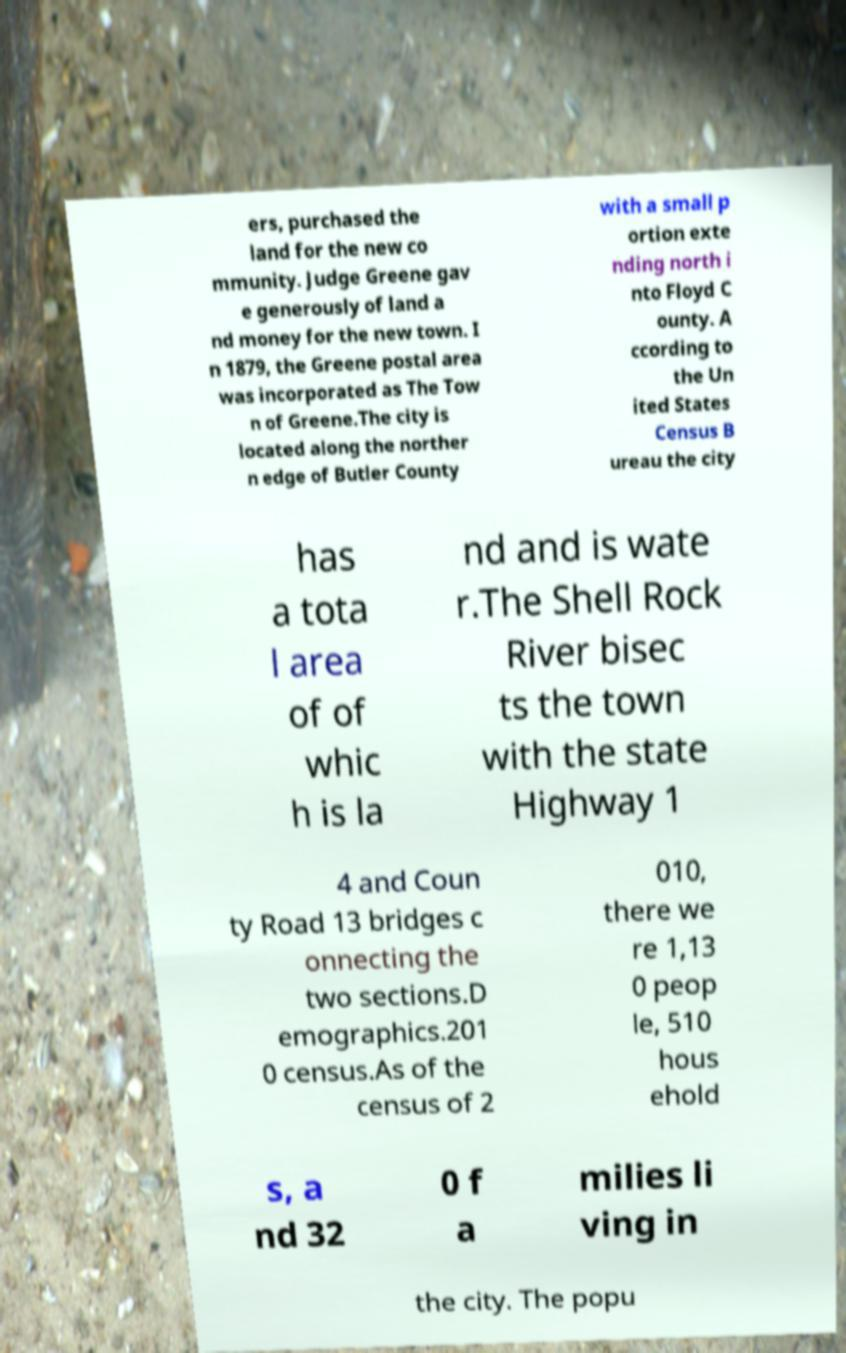I need the written content from this picture converted into text. Can you do that? ers, purchased the land for the new co mmunity. Judge Greene gav e generously of land a nd money for the new town. I n 1879, the Greene postal area was incorporated as The Tow n of Greene.The city is located along the norther n edge of Butler County with a small p ortion exte nding north i nto Floyd C ounty. A ccording to the Un ited States Census B ureau the city has a tota l area of of whic h is la nd and is wate r.The Shell Rock River bisec ts the town with the state Highway 1 4 and Coun ty Road 13 bridges c onnecting the two sections.D emographics.201 0 census.As of the census of 2 010, there we re 1,13 0 peop le, 510 hous ehold s, a nd 32 0 f a milies li ving in the city. The popu 